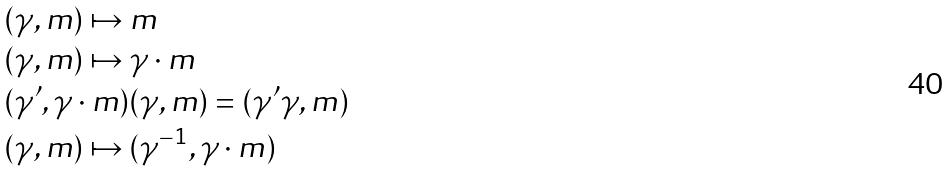Convert formula to latex. <formula><loc_0><loc_0><loc_500><loc_500>& ( \gamma , m ) \mapsto m \\ & ( \gamma , m ) \mapsto \gamma \cdot m \\ & ( \gamma ^ { \prime } , \gamma \cdot m ) ( \gamma , m ) = ( \gamma ^ { \prime } \gamma , m ) \\ & ( \gamma , m ) \mapsto ( \gamma ^ { - 1 } , \gamma \cdot m )</formula> 